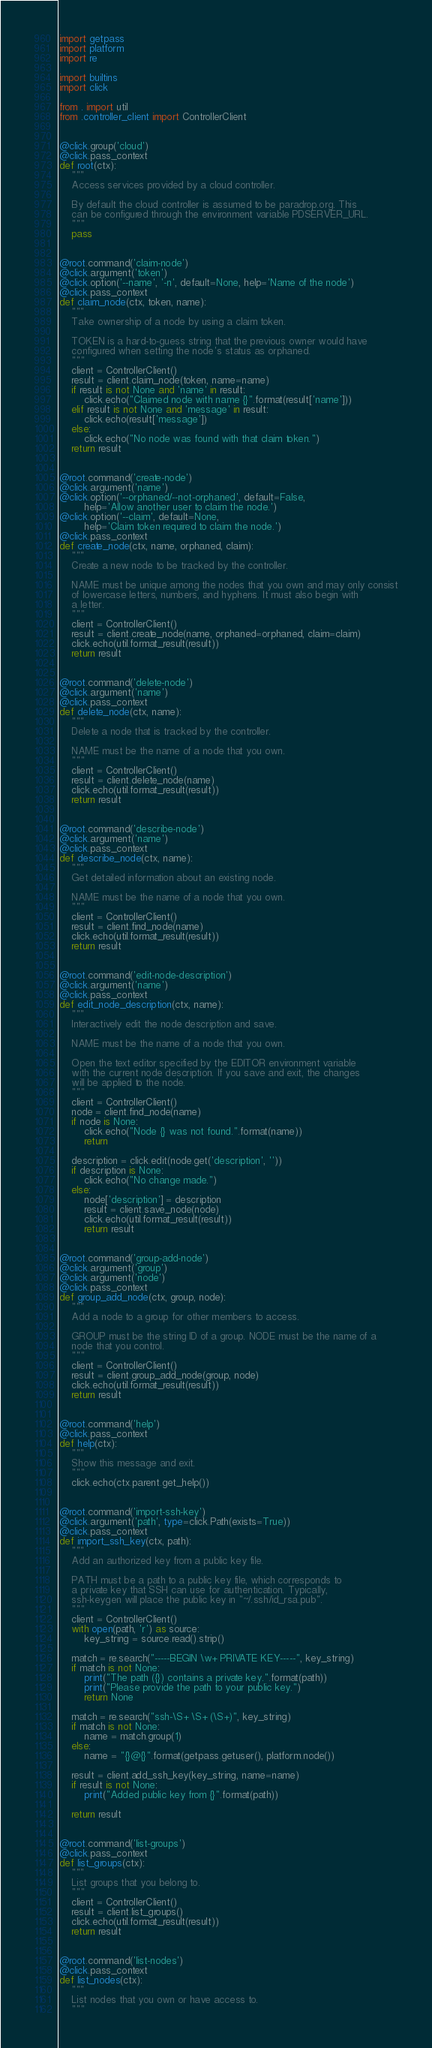Convert code to text. <code><loc_0><loc_0><loc_500><loc_500><_Python_>import getpass
import platform
import re

import builtins
import click

from . import util
from .controller_client import ControllerClient


@click.group('cloud')
@click.pass_context
def root(ctx):
    """
    Access services provided by a cloud controller.

    By default the cloud controller is assumed to be paradrop.org. This
    can be configured through the environment variable PDSERVER_URL.
    """
    pass


@root.command('claim-node')
@click.argument('token')
@click.option('--name', '-n', default=None, help='Name of the node')
@click.pass_context
def claim_node(ctx, token, name):
    """
    Take ownership of a node by using a claim token.

    TOKEN is a hard-to-guess string that the previous owner would have
    configured when setting the node's status as orphaned.
    """
    client = ControllerClient()
    result = client.claim_node(token, name=name)
    if result is not None and 'name' in result:
        click.echo("Claimed node with name {}".format(result['name']))
    elif result is not None and 'message' in result:
        click.echo(result['message'])
    else:
        click.echo("No node was found with that claim token.")
    return result


@root.command('create-node')
@click.argument('name')
@click.option('--orphaned/--not-orphaned', default=False,
        help='Allow another user to claim the node.')
@click.option('--claim', default=None,
        help='Claim token required to claim the node.')
@click.pass_context
def create_node(ctx, name, orphaned, claim):
    """
    Create a new node to be tracked by the controller.

    NAME must be unique among the nodes that you own and may only consist
    of lowercase letters, numbers, and hyphens. It must also begin with
    a letter.
    """
    client = ControllerClient()
    result = client.create_node(name, orphaned=orphaned, claim=claim)
    click.echo(util.format_result(result))
    return result


@root.command('delete-node')
@click.argument('name')
@click.pass_context
def delete_node(ctx, name):
    """
    Delete a node that is tracked by the controller.

    NAME must be the name of a node that you own.
    """
    client = ControllerClient()
    result = client.delete_node(name)
    click.echo(util.format_result(result))
    return result


@root.command('describe-node')
@click.argument('name')
@click.pass_context
def describe_node(ctx, name):
    """
    Get detailed information about an existing node.

    NAME must be the name of a node that you own.
    """
    client = ControllerClient()
    result = client.find_node(name)
    click.echo(util.format_result(result))
    return result


@root.command('edit-node-description')
@click.argument('name')
@click.pass_context
def edit_node_description(ctx, name):
    """
    Interactively edit the node description and save.

    NAME must be the name of a node that you own.

    Open the text editor specified by the EDITOR environment variable
    with the current node description. If you save and exit, the changes
    will be applied to the node.
    """
    client = ControllerClient()
    node = client.find_node(name)
    if node is None:
        click.echo("Node {} was not found.".format(name))
        return

    description = click.edit(node.get('description', ''))
    if description is None:
        click.echo("No change made.")
    else:
        node['description'] = description
        result = client.save_node(node)
        click.echo(util.format_result(result))
        return result


@root.command('group-add-node')
@click.argument('group')
@click.argument('node')
@click.pass_context
def group_add_node(ctx, group, node):
    """
    Add a node to a group for other members to access.

    GROUP must be the string ID of a group. NODE must be the name of a
    node that you control.
    """
    client = ControllerClient()
    result = client.group_add_node(group, node)
    click.echo(util.format_result(result))
    return result


@root.command('help')
@click.pass_context
def help(ctx):
    """
    Show this message and exit.
    """
    click.echo(ctx.parent.get_help())


@root.command('import-ssh-key')
@click.argument('path', type=click.Path(exists=True))
@click.pass_context
def import_ssh_key(ctx, path):
    """
    Add an authorized key from a public key file.

    PATH must be a path to a public key file, which corresponds to
    a private key that SSH can use for authentication. Typically,
    ssh-keygen will place the public key in "~/.ssh/id_rsa.pub".
    """
    client = ControllerClient()
    with open(path, 'r') as source:
        key_string = source.read().strip()

    match = re.search("-----BEGIN \w+ PRIVATE KEY-----", key_string)
    if match is not None:
        print("The path ({}) contains a private key.".format(path))
        print("Please provide the path to your public key.")
        return None

    match = re.search("ssh-\S+ \S+ (\S+)", key_string)
    if match is not None:
        name = match.group(1)
    else:
        name = "{}@{}".format(getpass.getuser(), platform.node())

    result = client.add_ssh_key(key_string, name=name)
    if result is not None:
        print("Added public key from {}".format(path))

    return result


@root.command('list-groups')
@click.pass_context
def list_groups(ctx):
    """
    List groups that you belong to.
    """
    client = ControllerClient()
    result = client.list_groups()
    click.echo(util.format_result(result))
    return result


@root.command('list-nodes')
@click.pass_context
def list_nodes(ctx):
    """
    List nodes that you own or have access to.
    """</code> 